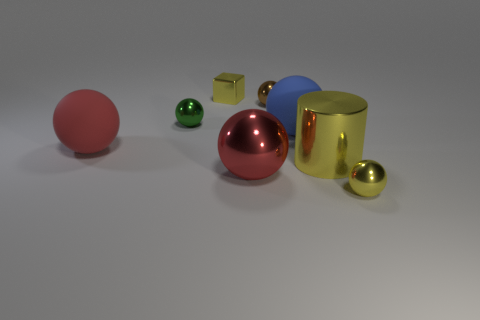Subtract 3 balls. How many balls are left? 3 Subtract all brown spheres. How many spheres are left? 5 Subtract all tiny yellow spheres. How many spheres are left? 5 Subtract all cyan spheres. Subtract all brown cubes. How many spheres are left? 6 Add 2 big shiny things. How many objects exist? 10 Subtract all blocks. How many objects are left? 7 Add 3 small yellow metallic cubes. How many small yellow metallic cubes are left? 4 Add 5 big gray metal things. How many big gray metal things exist? 5 Subtract 0 purple cylinders. How many objects are left? 8 Subtract all large red objects. Subtract all blue rubber things. How many objects are left? 5 